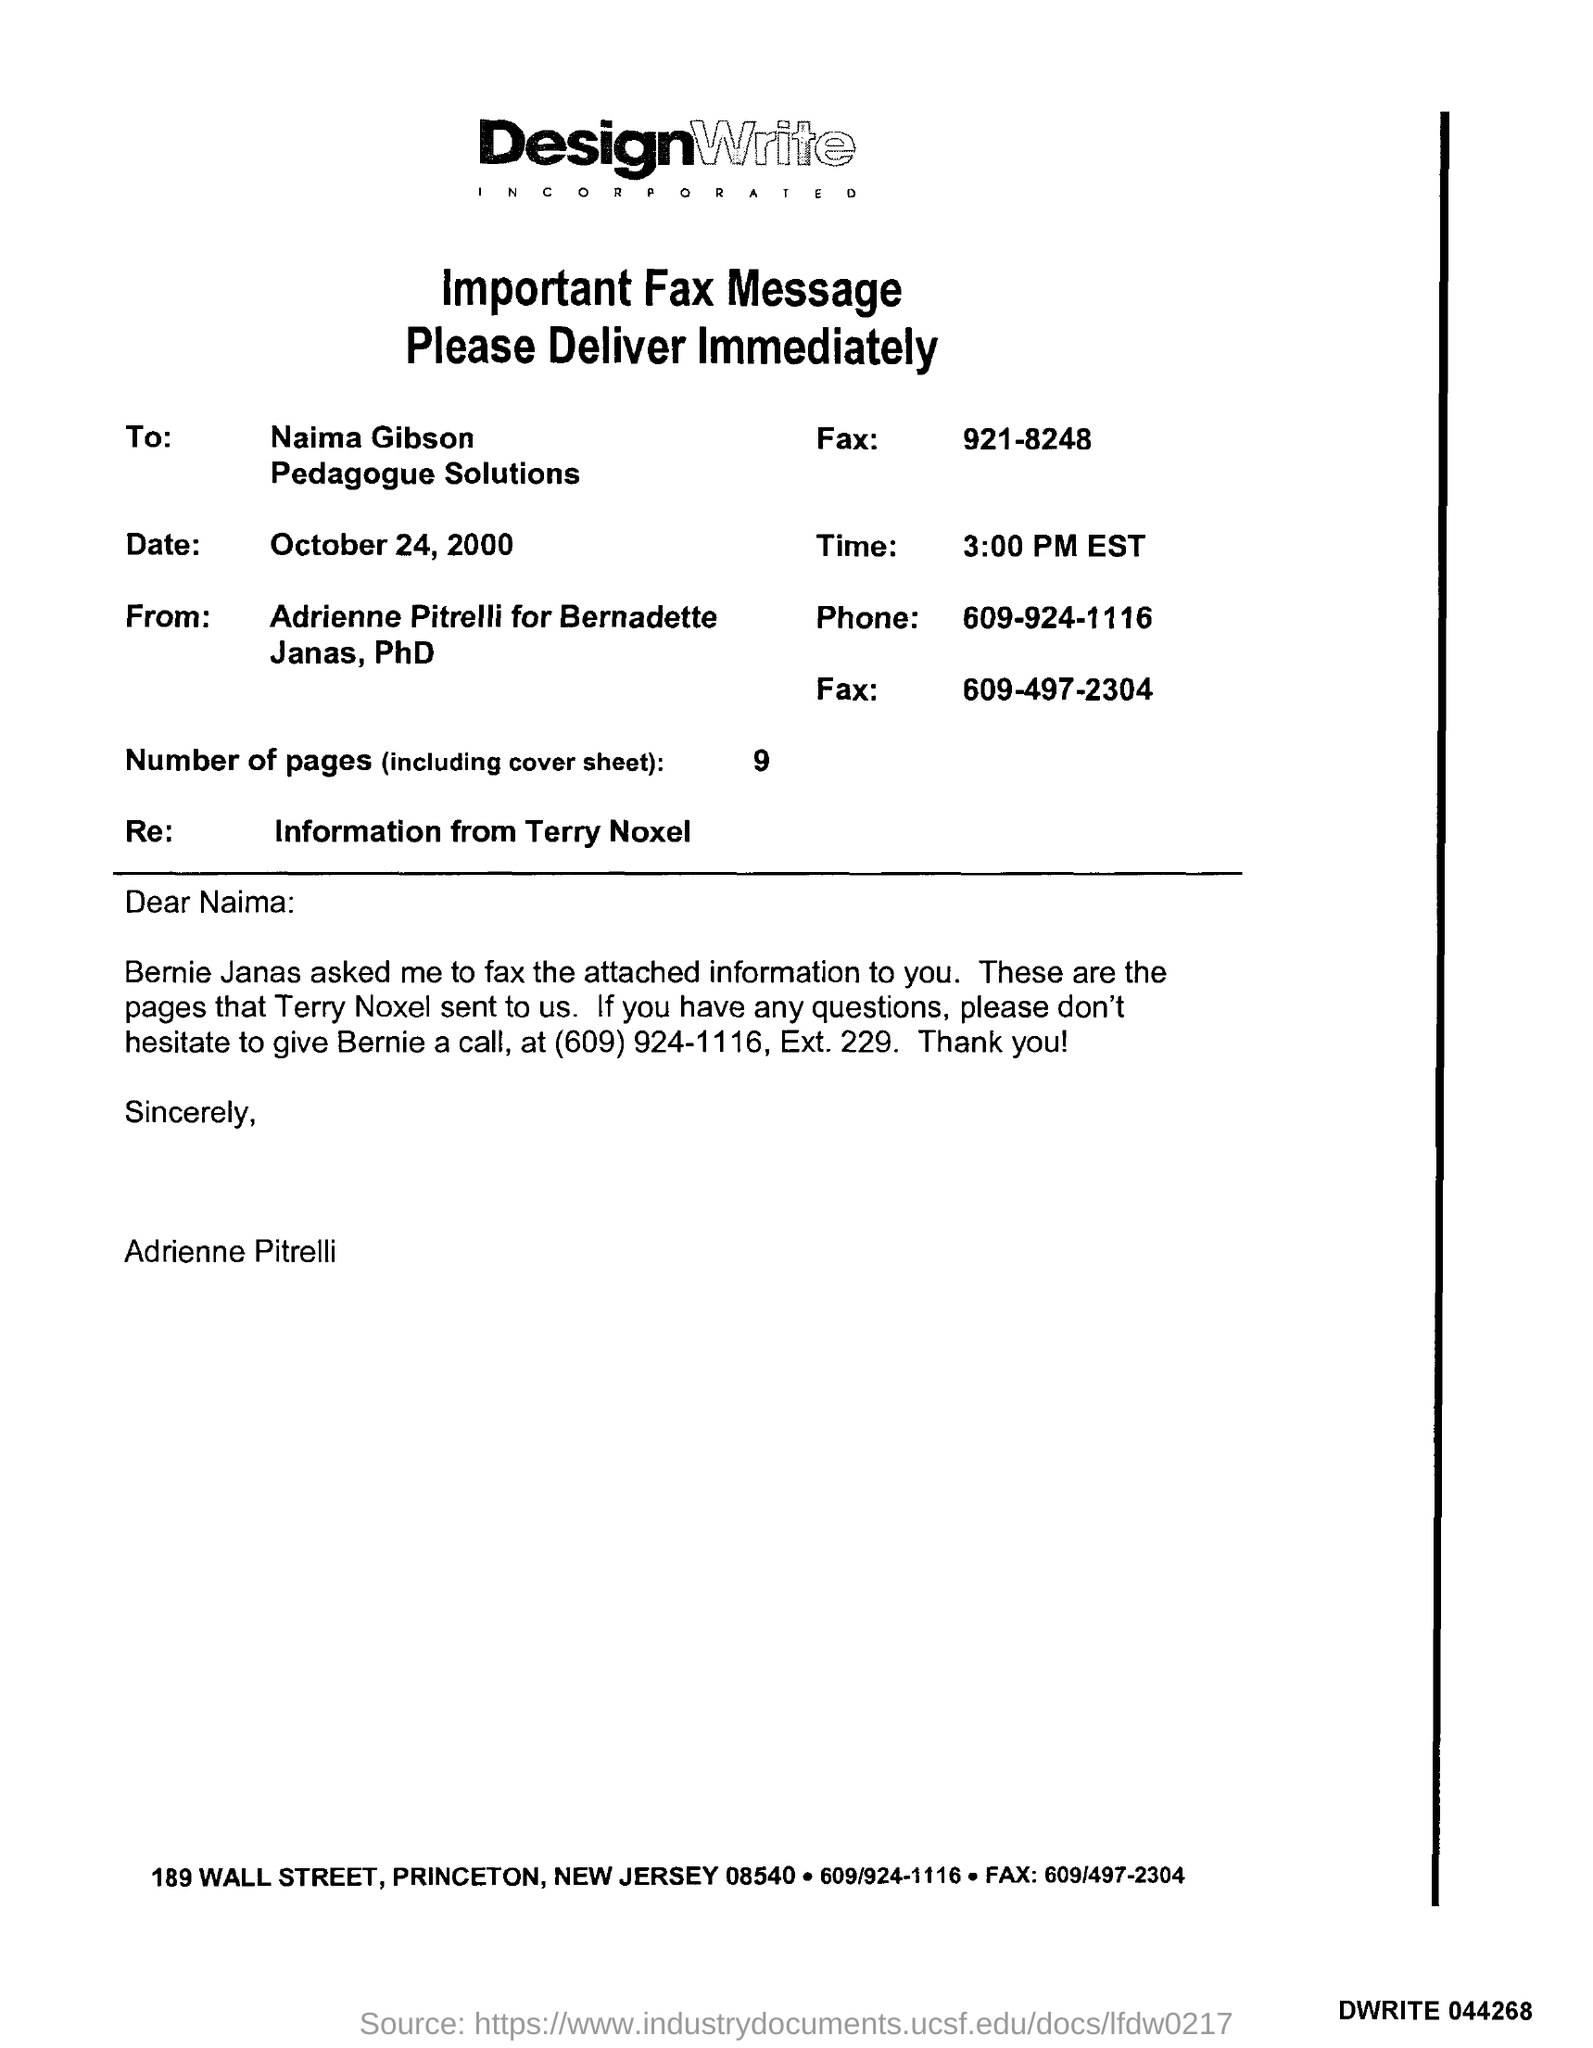Which company's fax message is this?
Provide a short and direct response. DesignWrite INCORPORATED. What is the date mentioned in the fax?
Make the answer very short. October 24, 2000. What is the time mentioned in the fax?
Your answer should be very brief. 3:00 PM EST. How many pages are there in the fax including cover sheet?
Your answer should be very brief. 9. 